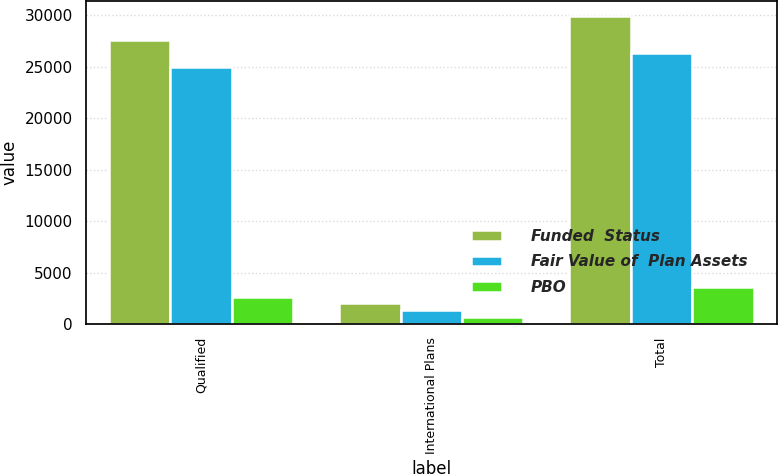<chart> <loc_0><loc_0><loc_500><loc_500><stacked_bar_chart><ecel><fcel>Qualified<fcel>International Plans<fcel>Total<nl><fcel>Funded  Status<fcel>27600<fcel>2043<fcel>29913<nl><fcel>Fair Value of  Plan Assets<fcel>24933<fcel>1379<fcel>26312<nl><fcel>PBO<fcel>2667<fcel>664<fcel>3601<nl></chart> 